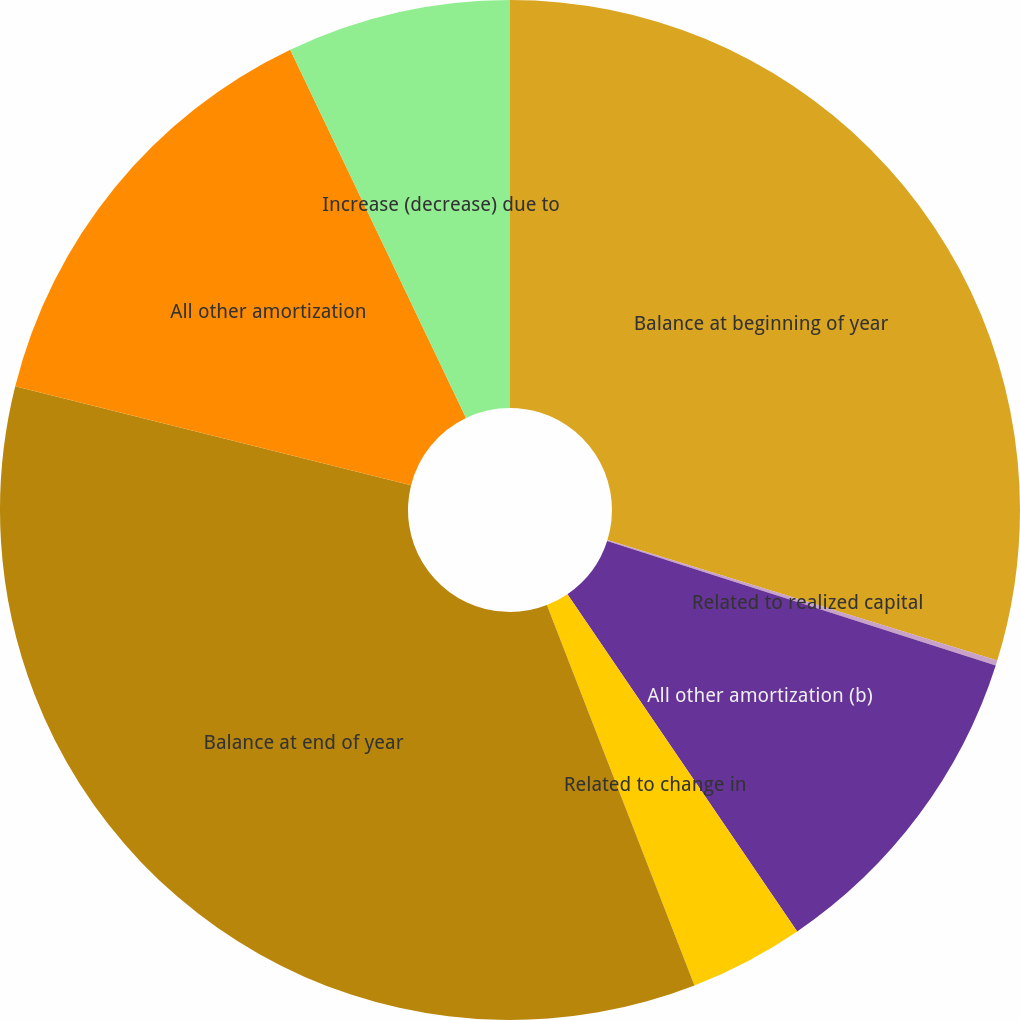<chart> <loc_0><loc_0><loc_500><loc_500><pie_chart><fcel>Balance at beginning of year<fcel>Related to realized capital<fcel>All other amortization (b)<fcel>Related to change in<fcel>Balance at end of year<fcel>All other amortization<fcel>Increase (decrease) due to<nl><fcel>29.77%<fcel>0.16%<fcel>10.55%<fcel>3.63%<fcel>34.79%<fcel>14.01%<fcel>7.09%<nl></chart> 